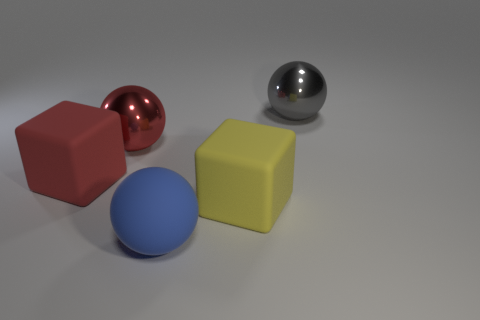Is the material of the large blue sphere the same as the gray ball?
Your answer should be compact. No. There is a red block that is made of the same material as the big yellow object; what is its size?
Provide a short and direct response. Large. What number of green objects are either large matte balls or large rubber blocks?
Give a very brief answer. 0. The rubber thing behind the large yellow cube has what shape?
Offer a terse response. Cube. The metallic thing that is the same size as the red sphere is what color?
Give a very brief answer. Gray. Does the red rubber object have the same shape as the metallic object on the left side of the big yellow block?
Provide a short and direct response. No. There is a cube that is to the left of the large red sphere on the right side of the big matte object to the left of the red metallic ball; what is it made of?
Make the answer very short. Rubber. What number of tiny objects are either metal balls or purple rubber objects?
Make the answer very short. 0. How many other things are the same size as the blue matte sphere?
Your answer should be compact. 4. There is a red object that is to the left of the red metal thing; is its shape the same as the red metallic thing?
Offer a terse response. No. 